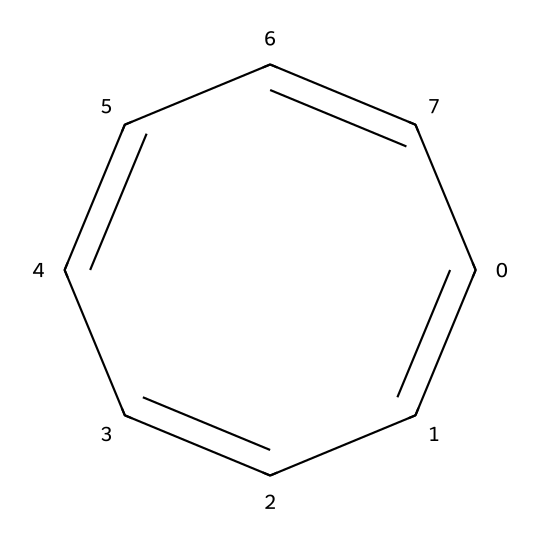What is the molecular formula of cyclooctatetraene? To determine the molecular formula, count the carbon and hydrogen atoms in the SMILES representation. The structure shows 8 carbon atoms and 8 hydrogen atoms, leading to the formula C8H8.
Answer: C8H8 How many double bonds are present in cyclooctatetraene? Inspecting the double bonds in the SMILES structure, there are 4 double bonds indicated between the carbon atoms (C=C), so the count is four.
Answer: 4 What type of hydrocarbon is cyclooctatetraene? Given that cyclooctatetraene consists entirely of carbon and hydrogen and contains alternating double bonds, it qualifies as a cyclic hydrocarbon, specifically a cycloalkene due to the presence of cyclic structure and double bonds.
Answer: cycloalkene Is cyclooctatetraene fully saturated? A compound is fully saturated if it contains the maximum number of hydrogen atoms possible for its number of carbon atoms, which is not the case here due to the presence of double bonds. Thus, cyclooctatetraene is not fully saturated.
Answer: no What kind of reaction can cyclooctatetraene undergo easily? Due to the presence of multiple double bonds, cyclooctatetraene can readily undergo addition reactions, making it quite reactive under suitable conditions.
Answer: addition Does cyclooctatetraene have a ring structure? Examining the SMILES representation reveals that the carbon atoms are connected in a cyclic manner, confirming the presence of a ring structure in cyclooctatetraene.
Answer: yes What is the total number of carbon atoms in the ring of cyclooctatetraene? The structure depicts a ring of 8 carbon atoms, indicating that the total number of carbon atoms in the cyclooctatetraene's ring is eight.
Answer: 8 